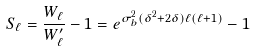Convert formula to latex. <formula><loc_0><loc_0><loc_500><loc_500>S _ { \ell } = \frac { W _ { \ell } } { W ^ { \prime } _ { \ell } } - 1 = e ^ { \sigma _ { b } ^ { 2 } ( \delta ^ { 2 } + 2 \delta ) \ell ( \ell + 1 ) } - 1</formula> 